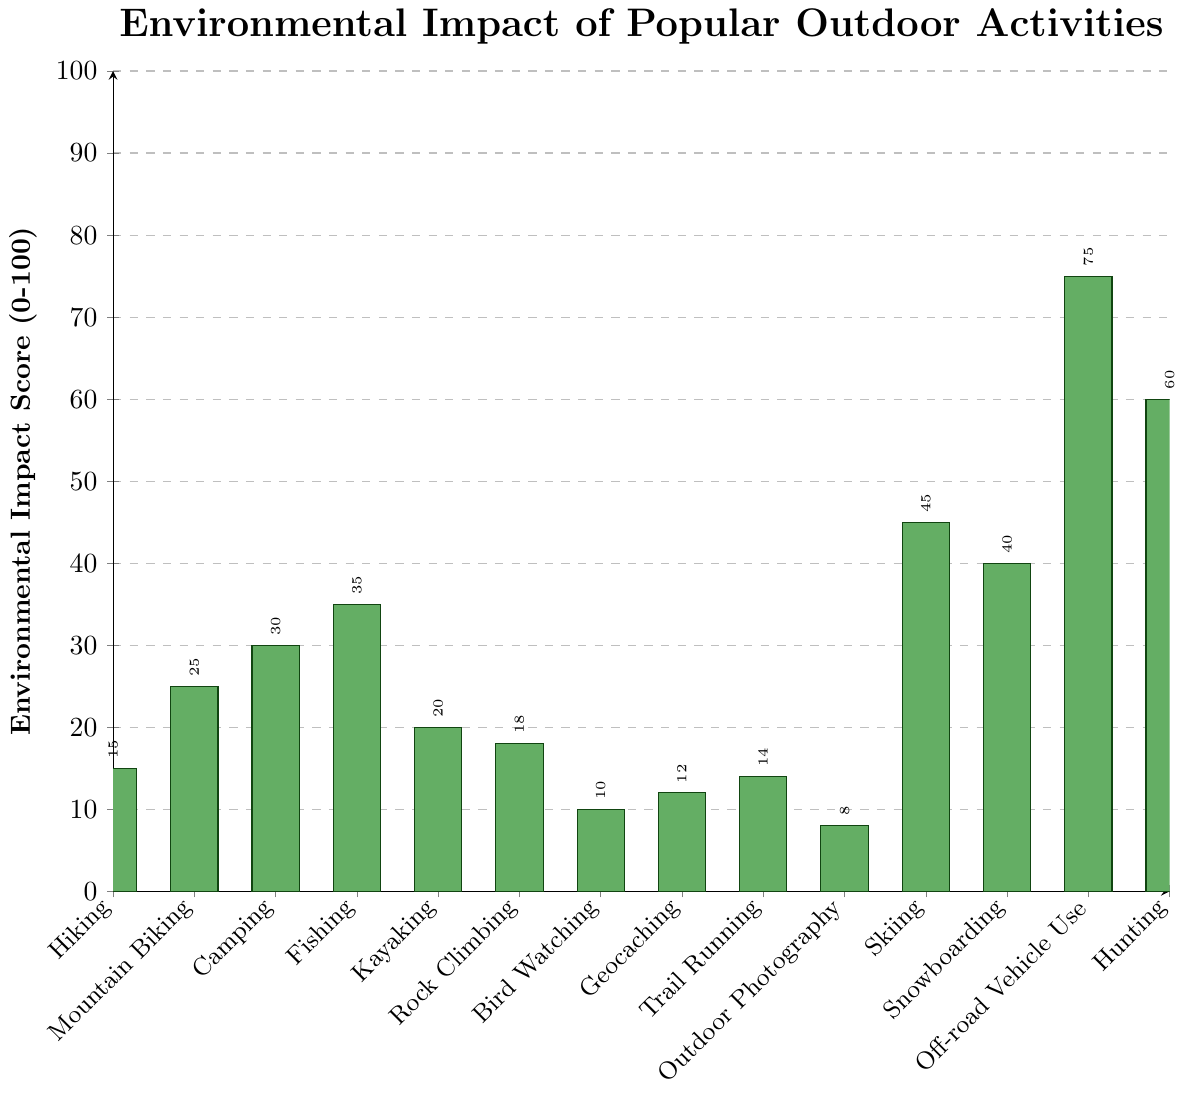Which activity has the lowest environmental impact score? To identify the activity with the lowest environmental impact, look for the shortest bar in the chart, which corresponds to Outdoor Photography.
Answer: Outdoor Photography Which activity has the highest environmental impact score? Look for the tallest bar in the chart, which represents the activity with the highest impact score, which is Off-road Vehicle Use.
Answer: Off-road Vehicle Use Compare the environmental impact scores of Hiking and Camping. Which one is higher and by how much? Hiking has an impact score of 15, and Camping has 30. The difference is calculated as 30 - 15.
Answer: Camping, 15 points higher What is the average environmental impact score of Kayaking, Rock Climbing, and Geocaching? Add the scores for Kayaking (20), Rock Climbing (18), and Geocaching (12) and divide by 3: (20 + 18 + 12) / 3 = 50 / 3.
Answer: 16.67 Does Mountain Biking have a higher environmental impact than Bird Watching? If yes, by how much? Mountain Biking has an impact score of 25, and Bird Watching has 10. The difference is calculated as 25 - 10.
Answer: Yes, by 15 points What's the combined environmental impact score of Fishing and Hunting? Add the scores for Fishing (35) and Hunting (60): 35 + 60.
Answer: 95 Which winter activity, Skiing or Snowboarding, has a higher environmental impact score, and by how much? Skiing has a score of 45, while Snowboarding has 40. The difference is calculated as 45 - 40.
Answer: Skiing, by 5 points What is the median environmental impact score of all the activities? Arrange the scores in ascending order: 8, 10, 12, 14, 15, 18, 20, 25, 30, 35, 40, 45, 60, 75. The median is the middle value, which is the 7th value: 20.
Answer: 20 How does the environmental impact score of Off-road Vehicle Use compare to that of Hunting? Off-road Vehicle Use has a score of 75, while Hunting has 60. The difference is calculated as 75 - 60.
Answer: Off-road Vehicle Use, 15 points higher What is the sum of the environmental impact scores for all non-winter activities (excluding Skiing and Snowboarding)? Exclude Skiing (45) and Snowboarding (40) and calculate the sum of the others: 15 (Hiking) + 25 (Mountain Biking) + 30 (Camping) + 35 (Fishing) + 20 (Kayaking) + 18 (Rock Climbing) + 10 (Bird Watching) + 12 (Geocaching) + 14 (Trail Running) + 8 (Outdoor Photography) + 75 (Off-road Vehicle Use) + 60 (Hunting) = 322.
Answer: 322 